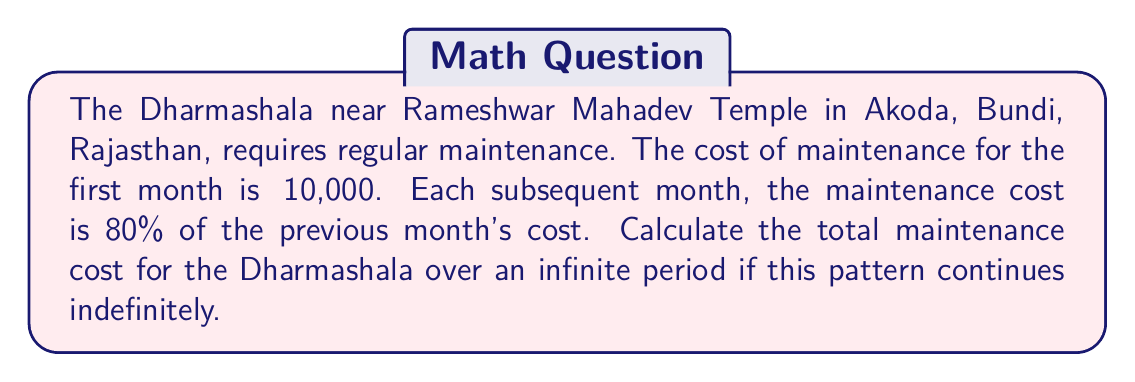Can you answer this question? Let's approach this step-by-step:

1) First, we need to identify the series. Let $a_n$ be the cost for the nth month.

   $a_1 = 10000$
   $a_2 = 10000 \cdot 0.8 = 8000$
   $a_3 = 8000 \cdot 0.8 = 6400$
   and so on...

2) We can see that this is a geometric series with:
   First term $a = 10000$
   Common ratio $r = 0.8$

3) The sum of an infinite geometric series is given by the formula:
   
   $$S_{\infty} = \frac{a}{1-r}$$

   Where $|r| < 1$ for the series to converge.

4) In this case, $|r| = 0.8 < 1$, so the series converges.

5) Substituting our values:

   $$S_{\infty} = \frac{10000}{1-0.8} = \frac{10000}{0.2}$$

6) Calculating:

   $$S_{\infty} = 50000$$

Therefore, the total maintenance cost over an infinite period would be ₹50,000.
Answer: ₹50,000 